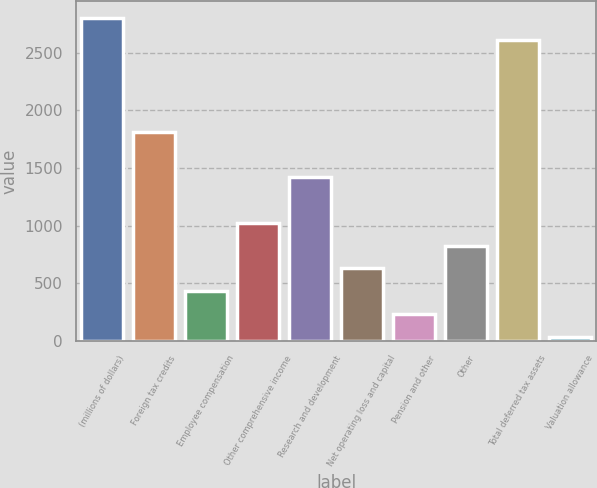Convert chart. <chart><loc_0><loc_0><loc_500><loc_500><bar_chart><fcel>(millions of dollars)<fcel>Foreign tax credits<fcel>Employee compensation<fcel>Other comprehensive income<fcel>Research and development<fcel>Net operating loss and capital<fcel>Pension and other<fcel>Other<fcel>Total deferred tax assets<fcel>Valuation allowance<nl><fcel>2804.52<fcel>1815.12<fcel>429.96<fcel>1023.6<fcel>1419.36<fcel>627.84<fcel>232.08<fcel>825.72<fcel>2606.64<fcel>34.2<nl></chart> 